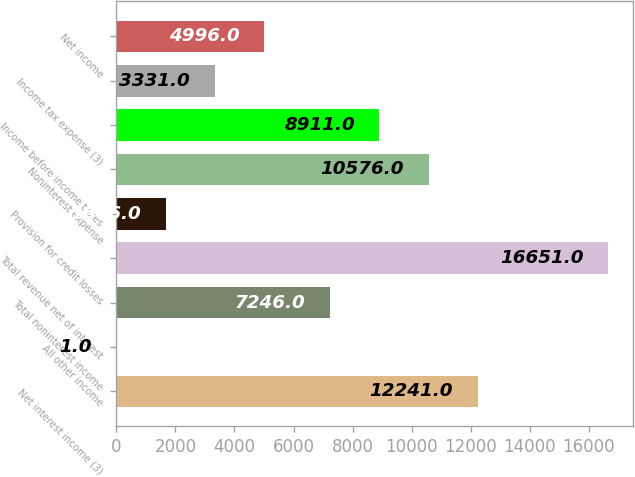Convert chart. <chart><loc_0><loc_0><loc_500><loc_500><bar_chart><fcel>Net interest income (3)<fcel>All other income<fcel>Total noninterest income<fcel>Total revenue net of interest<fcel>Provision for credit losses<fcel>Noninterest expense<fcel>Income before income taxes<fcel>Income tax expense (3)<fcel>Net income<nl><fcel>12241<fcel>1<fcel>7246<fcel>16651<fcel>1666<fcel>10576<fcel>8911<fcel>3331<fcel>4996<nl></chart> 